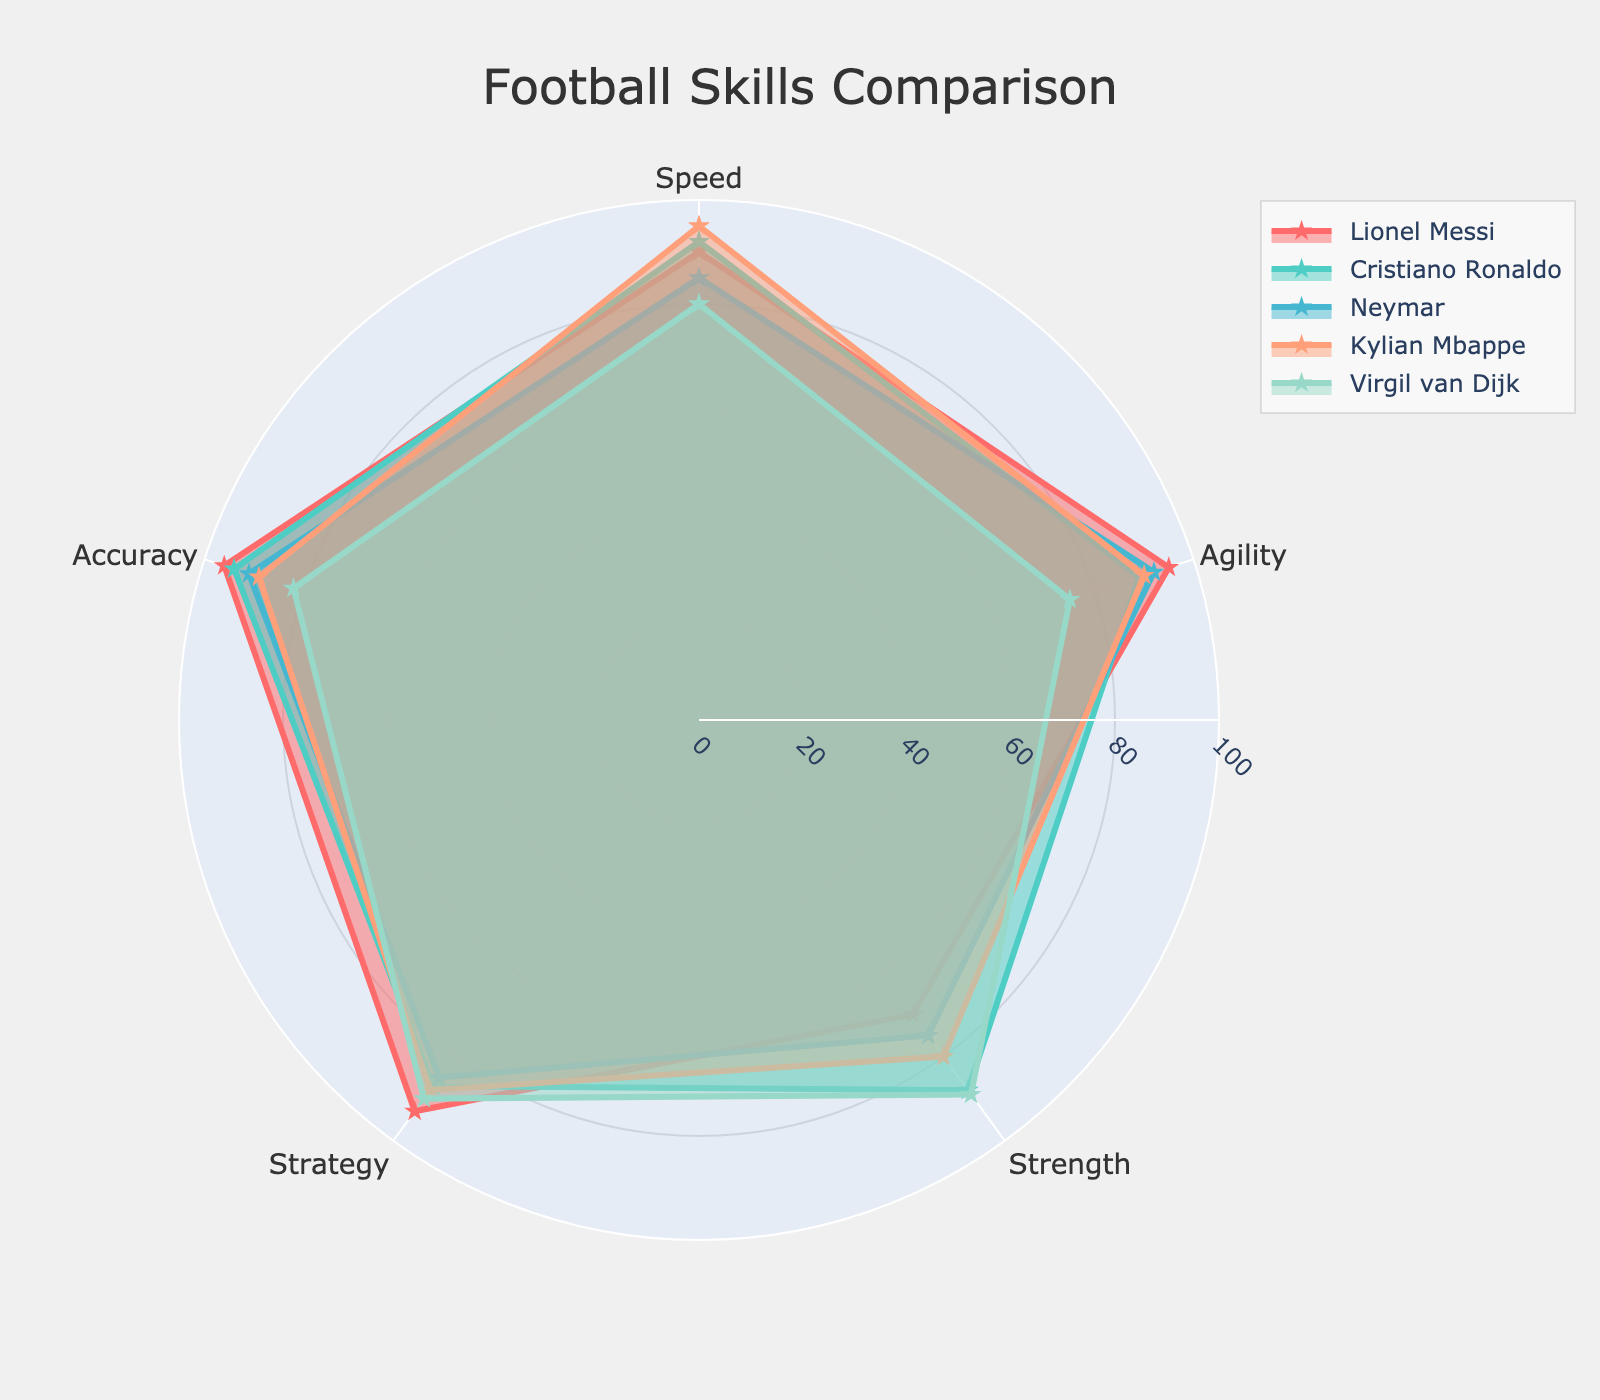What are the different skills compared in the radar chart? The radar chart compares five different skills: Speed, Agility, Strength, Strategy, and Accuracy. These skills are listed as the axes of the radar chart.
Answer: Speed, Agility, Strength, Strategy, Accuracy Who has the highest score in Accuracy? To find the highest score in Accuracy, look for the player whose point on the Accuracy axis is the furthest from the center. According to the data, Lionel Messi has the highest Accuracy score of 96.
Answer: Lionel Messi What is the average Strength score of all players? Add up the Strength scores of all players: 70 (Messi) + 88 (Ronaldo) + 75 (Neymar) + 80 (Mbappe) + 89 (van Dijk). Divide the total by the number of players (5). The calculation is (70 + 88 + 75 + 80 + 89) / 5 = 402 / 5, which equals 80.4.
Answer: 80.4 Between Lionel Messi and Kylian Mbappe, who has a higher Agility score and by how much? Check and compare the Agility scores of the two players. Messi has an Agility score of 95, while Mbappe has 90. Subtract the smaller from the larger: 95 - 90. Messi’s Agility score is higher by 5.
Answer: Messi, by 5 Who has the lowest score in Strategy? To determine the player with the lowest Strategy score, compare all the scores listed under the Strategy axis. The scores are 93 (Messi), 87 (Ronaldo), 85 (Neymar), 88 (Mbappe), and 90 (van Dijk). Neymar has the lowest score with 85.
Answer: Neymar Compare the Speed scores between Cristiano Ronaldo and Neymar. Who has a higher Speed score? Look at the Speed scores of Cristiano Ronaldo and Neymar. Ronaldo has a Speed score of 92, whereas Neymar has a Speed score of 85. Ronaldo has a higher Speed score.
Answer: Cristiano Ronaldo Among all the players, who has the highest average score across all skills? Calculate the average score for each player across all five skills. Messi: (90+95+70+93+96)/5 = 88.8, Ronaldo: (92+89+88+87+94)/5 = 90, Neymar: (85+92+75+85+91)/5 = 85.6, Mbappe: (95+90+80+88+89)/5 = 88.4, van Dijk: (80+75+89+90+82)/5 = 83.2. Cristiano Ronaldo has the highest average score of 90.
Answer: Cristiano Ronaldo What is the median score for Speed among all players? List the Speed scores in ascending order: 80 (van Dijk), 85 (Neymar), 90 (Messi), 92 (Ronaldo), 95 (Mbappe). The median score is the middle value in this ordered list, which is 90.
Answer: 90 How much higher is Virgil van Dijk's Strength score compared to Lionel Messi's? Compare the Strength scores: van Dijk has a Strength score of 89 and Messi has 70. The difference is calculated as 89 - 70. Van Dijk’s Strength score is higher by 19.
Answer: 19 Which players have an Agility score above 90? Check each player's Agility score: Messi (95), Ronaldo (89), Neymar (92), Mbappe (90), van Dijk (75). Only Messi and Neymar have Agility scores above 90.
Answer: Messi, Neymar 